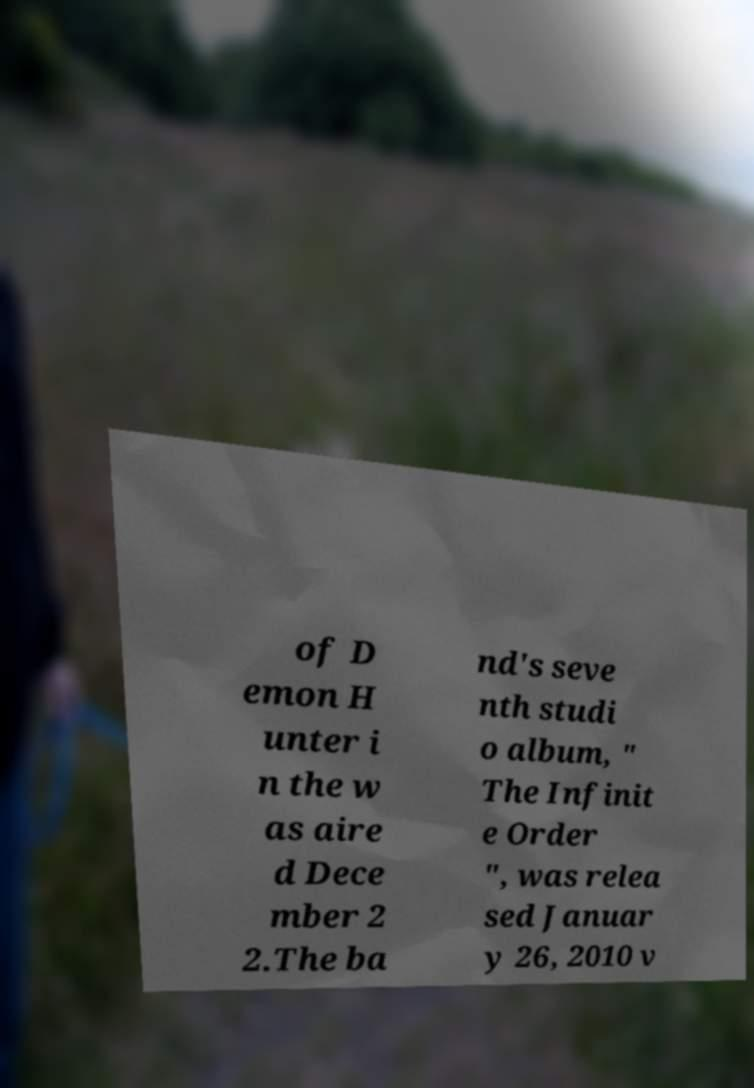Could you extract and type out the text from this image? of D emon H unter i n the w as aire d Dece mber 2 2.The ba nd's seve nth studi o album, " The Infinit e Order ", was relea sed Januar y 26, 2010 v 